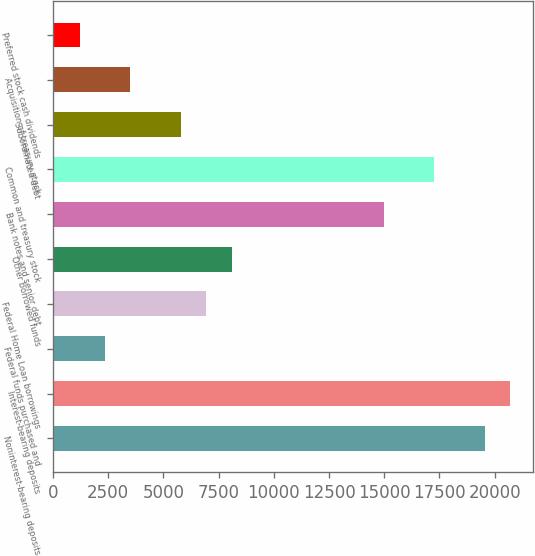Convert chart to OTSL. <chart><loc_0><loc_0><loc_500><loc_500><bar_chart><fcel>Noninterest-bearing deposits<fcel>Interest-bearing deposits<fcel>Federal funds purchased and<fcel>Federal Home Loan borrowings<fcel>Other borrowed funds<fcel>Bank notes and senior debt<fcel>Common and treasury stock<fcel>Subordinated debt<fcel>Acquisition of treasury stock<fcel>Preferred stock cash dividends<nl><fcel>19566.6<fcel>20714.4<fcel>2349.6<fcel>6940.8<fcel>8088.6<fcel>14975.4<fcel>17271<fcel>5793<fcel>3497.4<fcel>1201.8<nl></chart> 